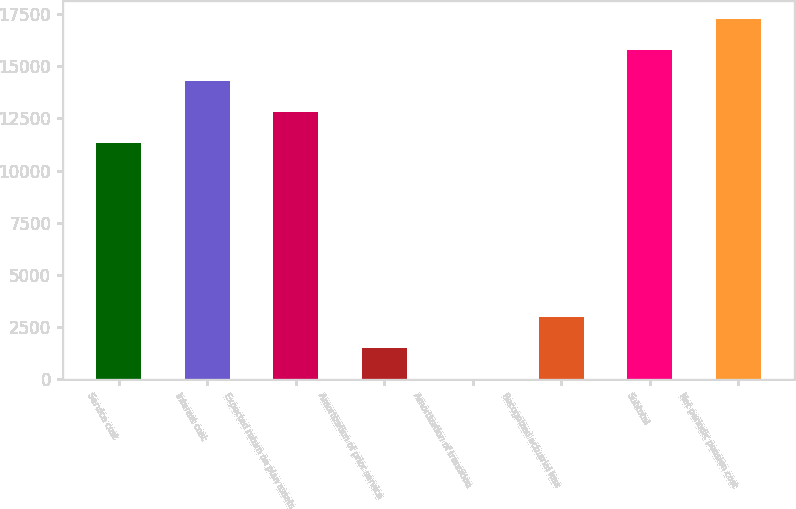Convert chart to OTSL. <chart><loc_0><loc_0><loc_500><loc_500><bar_chart><fcel>Service cost<fcel>Interest cost<fcel>Expected return on plan assets<fcel>Amortization of prior service<fcel>Amortization of transition<fcel>Recognized actuarial loss<fcel>Subtotal<fcel>Net periodic pension cost<nl><fcel>11323<fcel>14291.8<fcel>12807.4<fcel>1504.4<fcel>20<fcel>2999<fcel>15776.2<fcel>17260.6<nl></chart> 